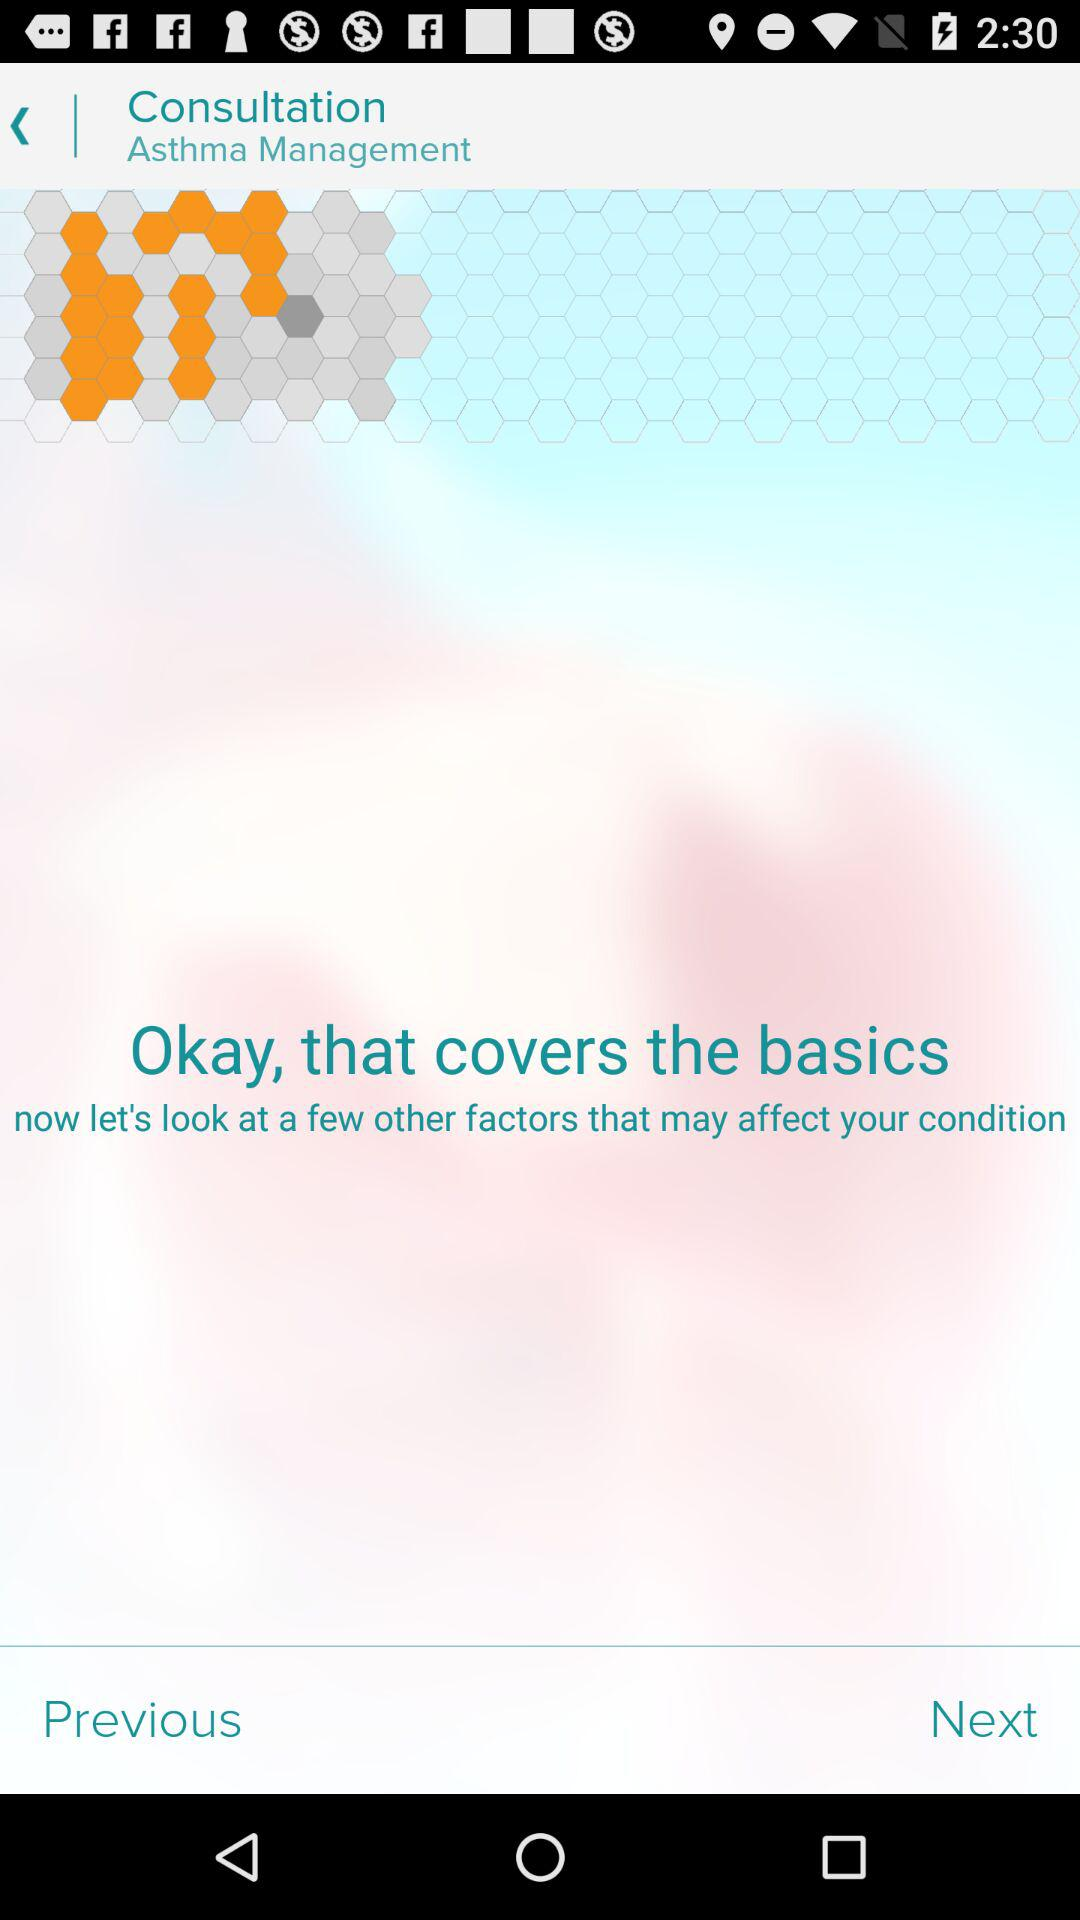What is the name of the consultation? The consultation name is "Asthma Management". 